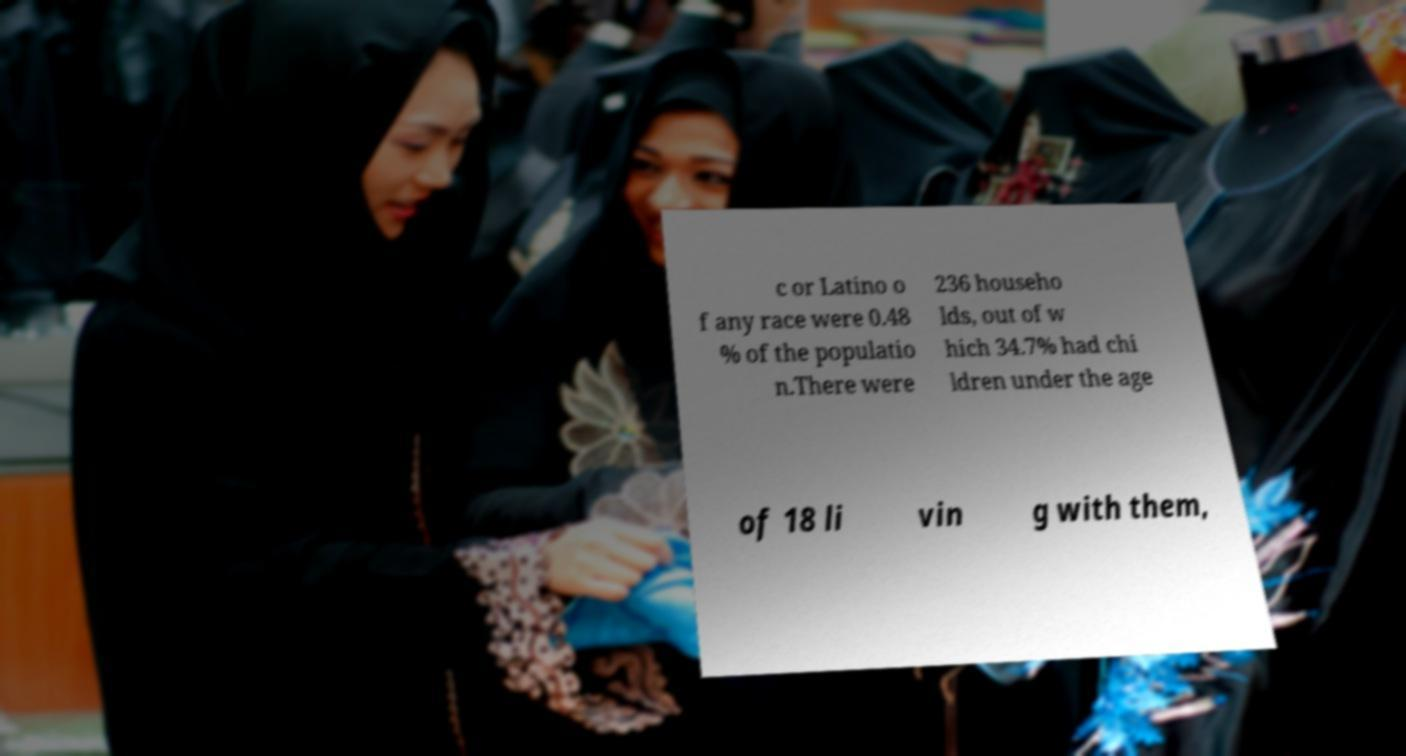Could you extract and type out the text from this image? c or Latino o f any race were 0.48 % of the populatio n.There were 236 househo lds, out of w hich 34.7% had chi ldren under the age of 18 li vin g with them, 